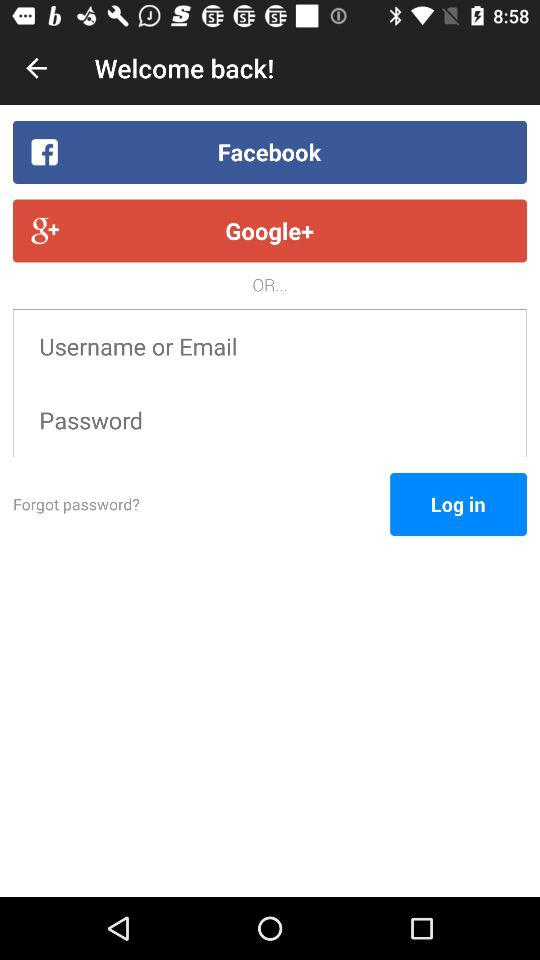What are the options for log in? The options for login are "Facebook" and "Google+". 